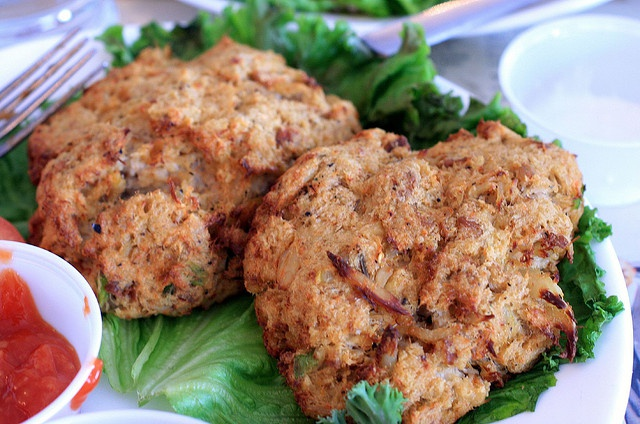Describe the objects in this image and their specific colors. I can see sandwich in lightblue, tan, brown, and salmon tones, sandwich in lightblue, salmon, tan, and brown tones, bowl in lightblue, lavender, and tan tones, bowl in lightblue, lavender, brown, and violet tones, and fork in lightblue, darkgray, lavender, and gray tones in this image. 